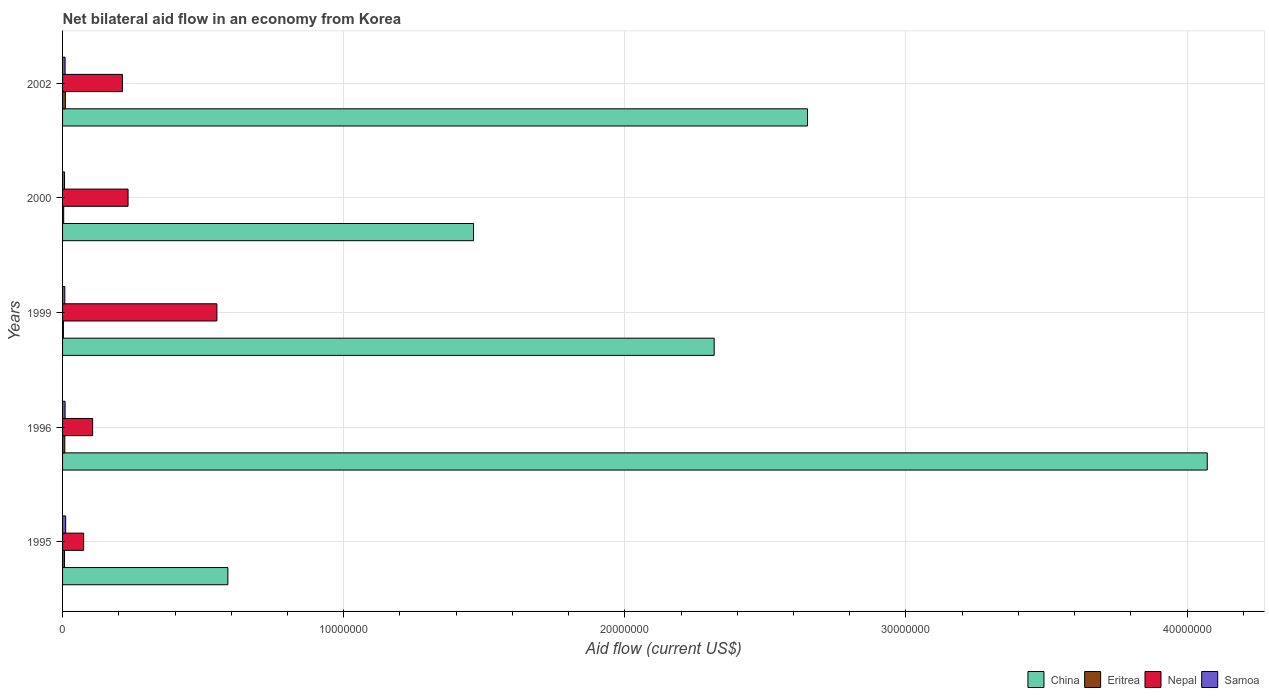Are the number of bars per tick equal to the number of legend labels?
Give a very brief answer. Yes. What is the net bilateral aid flow in Nepal in 2002?
Your answer should be very brief. 2.13e+06. Across all years, what is the maximum net bilateral aid flow in China?
Provide a short and direct response. 4.07e+07. Across all years, what is the minimum net bilateral aid flow in Eritrea?
Offer a very short reply. 3.00e+04. What is the total net bilateral aid flow in China in the graph?
Your response must be concise. 1.11e+08. What is the difference between the net bilateral aid flow in Samoa in 1999 and that in 2000?
Your response must be concise. 10000. What is the average net bilateral aid flow in Samoa per year?
Ensure brevity in your answer.  8.80e+04. In the year 1996, what is the difference between the net bilateral aid flow in China and net bilateral aid flow in Samoa?
Ensure brevity in your answer.  4.06e+07. What is the ratio of the net bilateral aid flow in Samoa in 1999 to that in 2000?
Your answer should be very brief. 1.14. Is the difference between the net bilateral aid flow in China in 1995 and 2002 greater than the difference between the net bilateral aid flow in Samoa in 1995 and 2002?
Provide a succinct answer. No. In how many years, is the net bilateral aid flow in Eritrea greater than the average net bilateral aid flow in Eritrea taken over all years?
Give a very brief answer. 3. What does the 4th bar from the top in 1996 represents?
Give a very brief answer. China. What does the 1st bar from the bottom in 2002 represents?
Keep it short and to the point. China. Are all the bars in the graph horizontal?
Offer a very short reply. Yes. How many years are there in the graph?
Provide a succinct answer. 5. Does the graph contain any zero values?
Offer a very short reply. No. Where does the legend appear in the graph?
Your answer should be compact. Bottom right. How many legend labels are there?
Offer a very short reply. 4. What is the title of the graph?
Your answer should be compact. Net bilateral aid flow in an economy from Korea. Does "Arab World" appear as one of the legend labels in the graph?
Your response must be concise. No. What is the label or title of the X-axis?
Keep it short and to the point. Aid flow (current US$). What is the Aid flow (current US$) of China in 1995?
Offer a very short reply. 5.88e+06. What is the Aid flow (current US$) in Eritrea in 1995?
Provide a short and direct response. 7.00e+04. What is the Aid flow (current US$) of Nepal in 1995?
Provide a succinct answer. 7.50e+05. What is the Aid flow (current US$) of Samoa in 1995?
Provide a short and direct response. 1.10e+05. What is the Aid flow (current US$) of China in 1996?
Ensure brevity in your answer.  4.07e+07. What is the Aid flow (current US$) of Eritrea in 1996?
Make the answer very short. 8.00e+04. What is the Aid flow (current US$) of Nepal in 1996?
Give a very brief answer. 1.07e+06. What is the Aid flow (current US$) in China in 1999?
Your answer should be compact. 2.32e+07. What is the Aid flow (current US$) of Eritrea in 1999?
Provide a short and direct response. 3.00e+04. What is the Aid flow (current US$) in Nepal in 1999?
Offer a very short reply. 5.49e+06. What is the Aid flow (current US$) in China in 2000?
Your answer should be compact. 1.46e+07. What is the Aid flow (current US$) in Nepal in 2000?
Offer a terse response. 2.33e+06. What is the Aid flow (current US$) in China in 2002?
Provide a short and direct response. 2.65e+07. What is the Aid flow (current US$) of Nepal in 2002?
Make the answer very short. 2.13e+06. What is the Aid flow (current US$) in Samoa in 2002?
Provide a short and direct response. 9.00e+04. Across all years, what is the maximum Aid flow (current US$) in China?
Keep it short and to the point. 4.07e+07. Across all years, what is the maximum Aid flow (current US$) in Nepal?
Make the answer very short. 5.49e+06. Across all years, what is the minimum Aid flow (current US$) in China?
Your answer should be compact. 5.88e+06. Across all years, what is the minimum Aid flow (current US$) in Eritrea?
Your answer should be very brief. 3.00e+04. Across all years, what is the minimum Aid flow (current US$) of Nepal?
Provide a short and direct response. 7.50e+05. What is the total Aid flow (current US$) of China in the graph?
Make the answer very short. 1.11e+08. What is the total Aid flow (current US$) of Nepal in the graph?
Provide a short and direct response. 1.18e+07. What is the total Aid flow (current US$) in Samoa in the graph?
Keep it short and to the point. 4.40e+05. What is the difference between the Aid flow (current US$) in China in 1995 and that in 1996?
Offer a very short reply. -3.48e+07. What is the difference between the Aid flow (current US$) of Nepal in 1995 and that in 1996?
Provide a short and direct response. -3.20e+05. What is the difference between the Aid flow (current US$) in Samoa in 1995 and that in 1996?
Your response must be concise. 2.00e+04. What is the difference between the Aid flow (current US$) of China in 1995 and that in 1999?
Offer a very short reply. -1.73e+07. What is the difference between the Aid flow (current US$) of Eritrea in 1995 and that in 1999?
Make the answer very short. 4.00e+04. What is the difference between the Aid flow (current US$) in Nepal in 1995 and that in 1999?
Offer a very short reply. -4.74e+06. What is the difference between the Aid flow (current US$) of Samoa in 1995 and that in 1999?
Provide a short and direct response. 3.00e+04. What is the difference between the Aid flow (current US$) in China in 1995 and that in 2000?
Give a very brief answer. -8.74e+06. What is the difference between the Aid flow (current US$) of Eritrea in 1995 and that in 2000?
Ensure brevity in your answer.  3.00e+04. What is the difference between the Aid flow (current US$) in Nepal in 1995 and that in 2000?
Ensure brevity in your answer.  -1.58e+06. What is the difference between the Aid flow (current US$) of Samoa in 1995 and that in 2000?
Make the answer very short. 4.00e+04. What is the difference between the Aid flow (current US$) in China in 1995 and that in 2002?
Ensure brevity in your answer.  -2.06e+07. What is the difference between the Aid flow (current US$) in Eritrea in 1995 and that in 2002?
Offer a very short reply. -3.00e+04. What is the difference between the Aid flow (current US$) in Nepal in 1995 and that in 2002?
Your response must be concise. -1.38e+06. What is the difference between the Aid flow (current US$) of China in 1996 and that in 1999?
Offer a terse response. 1.75e+07. What is the difference between the Aid flow (current US$) in Eritrea in 1996 and that in 1999?
Provide a short and direct response. 5.00e+04. What is the difference between the Aid flow (current US$) of Nepal in 1996 and that in 1999?
Offer a very short reply. -4.42e+06. What is the difference between the Aid flow (current US$) in Samoa in 1996 and that in 1999?
Your response must be concise. 10000. What is the difference between the Aid flow (current US$) of China in 1996 and that in 2000?
Give a very brief answer. 2.61e+07. What is the difference between the Aid flow (current US$) in Nepal in 1996 and that in 2000?
Keep it short and to the point. -1.26e+06. What is the difference between the Aid flow (current US$) of China in 1996 and that in 2002?
Make the answer very short. 1.42e+07. What is the difference between the Aid flow (current US$) of Nepal in 1996 and that in 2002?
Keep it short and to the point. -1.06e+06. What is the difference between the Aid flow (current US$) in Samoa in 1996 and that in 2002?
Your answer should be compact. 0. What is the difference between the Aid flow (current US$) of China in 1999 and that in 2000?
Provide a short and direct response. 8.56e+06. What is the difference between the Aid flow (current US$) in Nepal in 1999 and that in 2000?
Your answer should be very brief. 3.16e+06. What is the difference between the Aid flow (current US$) in China in 1999 and that in 2002?
Offer a terse response. -3.32e+06. What is the difference between the Aid flow (current US$) of Nepal in 1999 and that in 2002?
Your answer should be very brief. 3.36e+06. What is the difference between the Aid flow (current US$) in Samoa in 1999 and that in 2002?
Ensure brevity in your answer.  -10000. What is the difference between the Aid flow (current US$) in China in 2000 and that in 2002?
Provide a succinct answer. -1.19e+07. What is the difference between the Aid flow (current US$) of China in 1995 and the Aid flow (current US$) of Eritrea in 1996?
Make the answer very short. 5.80e+06. What is the difference between the Aid flow (current US$) of China in 1995 and the Aid flow (current US$) of Nepal in 1996?
Provide a short and direct response. 4.81e+06. What is the difference between the Aid flow (current US$) of China in 1995 and the Aid flow (current US$) of Samoa in 1996?
Provide a short and direct response. 5.79e+06. What is the difference between the Aid flow (current US$) of Eritrea in 1995 and the Aid flow (current US$) of Nepal in 1996?
Your answer should be very brief. -1.00e+06. What is the difference between the Aid flow (current US$) in Eritrea in 1995 and the Aid flow (current US$) in Samoa in 1996?
Offer a very short reply. -2.00e+04. What is the difference between the Aid flow (current US$) in Nepal in 1995 and the Aid flow (current US$) in Samoa in 1996?
Offer a very short reply. 6.60e+05. What is the difference between the Aid flow (current US$) in China in 1995 and the Aid flow (current US$) in Eritrea in 1999?
Provide a short and direct response. 5.85e+06. What is the difference between the Aid flow (current US$) in China in 1995 and the Aid flow (current US$) in Samoa in 1999?
Offer a very short reply. 5.80e+06. What is the difference between the Aid flow (current US$) of Eritrea in 1995 and the Aid flow (current US$) of Nepal in 1999?
Your answer should be compact. -5.42e+06. What is the difference between the Aid flow (current US$) in Eritrea in 1995 and the Aid flow (current US$) in Samoa in 1999?
Your answer should be very brief. -10000. What is the difference between the Aid flow (current US$) of Nepal in 1995 and the Aid flow (current US$) of Samoa in 1999?
Keep it short and to the point. 6.70e+05. What is the difference between the Aid flow (current US$) in China in 1995 and the Aid flow (current US$) in Eritrea in 2000?
Offer a very short reply. 5.84e+06. What is the difference between the Aid flow (current US$) in China in 1995 and the Aid flow (current US$) in Nepal in 2000?
Ensure brevity in your answer.  3.55e+06. What is the difference between the Aid flow (current US$) of China in 1995 and the Aid flow (current US$) of Samoa in 2000?
Give a very brief answer. 5.81e+06. What is the difference between the Aid flow (current US$) of Eritrea in 1995 and the Aid flow (current US$) of Nepal in 2000?
Offer a very short reply. -2.26e+06. What is the difference between the Aid flow (current US$) of Nepal in 1995 and the Aid flow (current US$) of Samoa in 2000?
Provide a short and direct response. 6.80e+05. What is the difference between the Aid flow (current US$) in China in 1995 and the Aid flow (current US$) in Eritrea in 2002?
Offer a very short reply. 5.78e+06. What is the difference between the Aid flow (current US$) in China in 1995 and the Aid flow (current US$) in Nepal in 2002?
Offer a very short reply. 3.75e+06. What is the difference between the Aid flow (current US$) of China in 1995 and the Aid flow (current US$) of Samoa in 2002?
Provide a succinct answer. 5.79e+06. What is the difference between the Aid flow (current US$) of Eritrea in 1995 and the Aid flow (current US$) of Nepal in 2002?
Provide a succinct answer. -2.06e+06. What is the difference between the Aid flow (current US$) in Eritrea in 1995 and the Aid flow (current US$) in Samoa in 2002?
Offer a very short reply. -2.00e+04. What is the difference between the Aid flow (current US$) of Nepal in 1995 and the Aid flow (current US$) of Samoa in 2002?
Make the answer very short. 6.60e+05. What is the difference between the Aid flow (current US$) of China in 1996 and the Aid flow (current US$) of Eritrea in 1999?
Your answer should be very brief. 4.07e+07. What is the difference between the Aid flow (current US$) of China in 1996 and the Aid flow (current US$) of Nepal in 1999?
Ensure brevity in your answer.  3.52e+07. What is the difference between the Aid flow (current US$) in China in 1996 and the Aid flow (current US$) in Samoa in 1999?
Make the answer very short. 4.06e+07. What is the difference between the Aid flow (current US$) of Eritrea in 1996 and the Aid flow (current US$) of Nepal in 1999?
Make the answer very short. -5.41e+06. What is the difference between the Aid flow (current US$) in Eritrea in 1996 and the Aid flow (current US$) in Samoa in 1999?
Your answer should be very brief. 0. What is the difference between the Aid flow (current US$) in Nepal in 1996 and the Aid flow (current US$) in Samoa in 1999?
Make the answer very short. 9.90e+05. What is the difference between the Aid flow (current US$) in China in 1996 and the Aid flow (current US$) in Eritrea in 2000?
Offer a terse response. 4.07e+07. What is the difference between the Aid flow (current US$) in China in 1996 and the Aid flow (current US$) in Nepal in 2000?
Offer a terse response. 3.84e+07. What is the difference between the Aid flow (current US$) of China in 1996 and the Aid flow (current US$) of Samoa in 2000?
Give a very brief answer. 4.06e+07. What is the difference between the Aid flow (current US$) in Eritrea in 1996 and the Aid flow (current US$) in Nepal in 2000?
Your answer should be compact. -2.25e+06. What is the difference between the Aid flow (current US$) of Eritrea in 1996 and the Aid flow (current US$) of Samoa in 2000?
Your response must be concise. 10000. What is the difference between the Aid flow (current US$) in China in 1996 and the Aid flow (current US$) in Eritrea in 2002?
Give a very brief answer. 4.06e+07. What is the difference between the Aid flow (current US$) of China in 1996 and the Aid flow (current US$) of Nepal in 2002?
Give a very brief answer. 3.86e+07. What is the difference between the Aid flow (current US$) of China in 1996 and the Aid flow (current US$) of Samoa in 2002?
Provide a succinct answer. 4.06e+07. What is the difference between the Aid flow (current US$) in Eritrea in 1996 and the Aid flow (current US$) in Nepal in 2002?
Keep it short and to the point. -2.05e+06. What is the difference between the Aid flow (current US$) in Eritrea in 1996 and the Aid flow (current US$) in Samoa in 2002?
Keep it short and to the point. -10000. What is the difference between the Aid flow (current US$) in Nepal in 1996 and the Aid flow (current US$) in Samoa in 2002?
Provide a succinct answer. 9.80e+05. What is the difference between the Aid flow (current US$) of China in 1999 and the Aid flow (current US$) of Eritrea in 2000?
Your answer should be very brief. 2.31e+07. What is the difference between the Aid flow (current US$) in China in 1999 and the Aid flow (current US$) in Nepal in 2000?
Your response must be concise. 2.08e+07. What is the difference between the Aid flow (current US$) of China in 1999 and the Aid flow (current US$) of Samoa in 2000?
Make the answer very short. 2.31e+07. What is the difference between the Aid flow (current US$) of Eritrea in 1999 and the Aid flow (current US$) of Nepal in 2000?
Make the answer very short. -2.30e+06. What is the difference between the Aid flow (current US$) in Eritrea in 1999 and the Aid flow (current US$) in Samoa in 2000?
Keep it short and to the point. -4.00e+04. What is the difference between the Aid flow (current US$) of Nepal in 1999 and the Aid flow (current US$) of Samoa in 2000?
Offer a terse response. 5.42e+06. What is the difference between the Aid flow (current US$) of China in 1999 and the Aid flow (current US$) of Eritrea in 2002?
Offer a terse response. 2.31e+07. What is the difference between the Aid flow (current US$) of China in 1999 and the Aid flow (current US$) of Nepal in 2002?
Keep it short and to the point. 2.10e+07. What is the difference between the Aid flow (current US$) in China in 1999 and the Aid flow (current US$) in Samoa in 2002?
Offer a very short reply. 2.31e+07. What is the difference between the Aid flow (current US$) in Eritrea in 1999 and the Aid flow (current US$) in Nepal in 2002?
Offer a very short reply. -2.10e+06. What is the difference between the Aid flow (current US$) in Eritrea in 1999 and the Aid flow (current US$) in Samoa in 2002?
Provide a short and direct response. -6.00e+04. What is the difference between the Aid flow (current US$) of Nepal in 1999 and the Aid flow (current US$) of Samoa in 2002?
Provide a short and direct response. 5.40e+06. What is the difference between the Aid flow (current US$) of China in 2000 and the Aid flow (current US$) of Eritrea in 2002?
Offer a very short reply. 1.45e+07. What is the difference between the Aid flow (current US$) of China in 2000 and the Aid flow (current US$) of Nepal in 2002?
Offer a terse response. 1.25e+07. What is the difference between the Aid flow (current US$) in China in 2000 and the Aid flow (current US$) in Samoa in 2002?
Offer a terse response. 1.45e+07. What is the difference between the Aid flow (current US$) of Eritrea in 2000 and the Aid flow (current US$) of Nepal in 2002?
Make the answer very short. -2.09e+06. What is the difference between the Aid flow (current US$) in Nepal in 2000 and the Aid flow (current US$) in Samoa in 2002?
Offer a very short reply. 2.24e+06. What is the average Aid flow (current US$) in China per year?
Your answer should be compact. 2.22e+07. What is the average Aid flow (current US$) of Eritrea per year?
Offer a terse response. 6.40e+04. What is the average Aid flow (current US$) of Nepal per year?
Provide a short and direct response. 2.35e+06. What is the average Aid flow (current US$) of Samoa per year?
Give a very brief answer. 8.80e+04. In the year 1995, what is the difference between the Aid flow (current US$) of China and Aid flow (current US$) of Eritrea?
Offer a terse response. 5.81e+06. In the year 1995, what is the difference between the Aid flow (current US$) of China and Aid flow (current US$) of Nepal?
Give a very brief answer. 5.13e+06. In the year 1995, what is the difference between the Aid flow (current US$) of China and Aid flow (current US$) of Samoa?
Make the answer very short. 5.77e+06. In the year 1995, what is the difference between the Aid flow (current US$) in Eritrea and Aid flow (current US$) in Nepal?
Your answer should be very brief. -6.80e+05. In the year 1995, what is the difference between the Aid flow (current US$) in Nepal and Aid flow (current US$) in Samoa?
Offer a very short reply. 6.40e+05. In the year 1996, what is the difference between the Aid flow (current US$) of China and Aid flow (current US$) of Eritrea?
Your response must be concise. 4.06e+07. In the year 1996, what is the difference between the Aid flow (current US$) of China and Aid flow (current US$) of Nepal?
Provide a short and direct response. 3.96e+07. In the year 1996, what is the difference between the Aid flow (current US$) of China and Aid flow (current US$) of Samoa?
Offer a terse response. 4.06e+07. In the year 1996, what is the difference between the Aid flow (current US$) of Eritrea and Aid flow (current US$) of Nepal?
Your answer should be very brief. -9.90e+05. In the year 1996, what is the difference between the Aid flow (current US$) in Eritrea and Aid flow (current US$) in Samoa?
Your response must be concise. -10000. In the year 1996, what is the difference between the Aid flow (current US$) of Nepal and Aid flow (current US$) of Samoa?
Provide a short and direct response. 9.80e+05. In the year 1999, what is the difference between the Aid flow (current US$) of China and Aid flow (current US$) of Eritrea?
Provide a short and direct response. 2.32e+07. In the year 1999, what is the difference between the Aid flow (current US$) of China and Aid flow (current US$) of Nepal?
Make the answer very short. 1.77e+07. In the year 1999, what is the difference between the Aid flow (current US$) in China and Aid flow (current US$) in Samoa?
Give a very brief answer. 2.31e+07. In the year 1999, what is the difference between the Aid flow (current US$) of Eritrea and Aid flow (current US$) of Nepal?
Your response must be concise. -5.46e+06. In the year 1999, what is the difference between the Aid flow (current US$) of Eritrea and Aid flow (current US$) of Samoa?
Provide a succinct answer. -5.00e+04. In the year 1999, what is the difference between the Aid flow (current US$) in Nepal and Aid flow (current US$) in Samoa?
Offer a terse response. 5.41e+06. In the year 2000, what is the difference between the Aid flow (current US$) in China and Aid flow (current US$) in Eritrea?
Provide a short and direct response. 1.46e+07. In the year 2000, what is the difference between the Aid flow (current US$) in China and Aid flow (current US$) in Nepal?
Your answer should be compact. 1.23e+07. In the year 2000, what is the difference between the Aid flow (current US$) in China and Aid flow (current US$) in Samoa?
Your answer should be compact. 1.46e+07. In the year 2000, what is the difference between the Aid flow (current US$) of Eritrea and Aid flow (current US$) of Nepal?
Offer a very short reply. -2.29e+06. In the year 2000, what is the difference between the Aid flow (current US$) in Nepal and Aid flow (current US$) in Samoa?
Ensure brevity in your answer.  2.26e+06. In the year 2002, what is the difference between the Aid flow (current US$) in China and Aid flow (current US$) in Eritrea?
Ensure brevity in your answer.  2.64e+07. In the year 2002, what is the difference between the Aid flow (current US$) in China and Aid flow (current US$) in Nepal?
Ensure brevity in your answer.  2.44e+07. In the year 2002, what is the difference between the Aid flow (current US$) in China and Aid flow (current US$) in Samoa?
Keep it short and to the point. 2.64e+07. In the year 2002, what is the difference between the Aid flow (current US$) of Eritrea and Aid flow (current US$) of Nepal?
Provide a succinct answer. -2.03e+06. In the year 2002, what is the difference between the Aid flow (current US$) of Eritrea and Aid flow (current US$) of Samoa?
Provide a short and direct response. 10000. In the year 2002, what is the difference between the Aid flow (current US$) in Nepal and Aid flow (current US$) in Samoa?
Keep it short and to the point. 2.04e+06. What is the ratio of the Aid flow (current US$) in China in 1995 to that in 1996?
Your response must be concise. 0.14. What is the ratio of the Aid flow (current US$) of Eritrea in 1995 to that in 1996?
Offer a terse response. 0.88. What is the ratio of the Aid flow (current US$) in Nepal in 1995 to that in 1996?
Keep it short and to the point. 0.7. What is the ratio of the Aid flow (current US$) in Samoa in 1995 to that in 1996?
Make the answer very short. 1.22. What is the ratio of the Aid flow (current US$) of China in 1995 to that in 1999?
Offer a terse response. 0.25. What is the ratio of the Aid flow (current US$) in Eritrea in 1995 to that in 1999?
Make the answer very short. 2.33. What is the ratio of the Aid flow (current US$) in Nepal in 1995 to that in 1999?
Your answer should be very brief. 0.14. What is the ratio of the Aid flow (current US$) in Samoa in 1995 to that in 1999?
Offer a terse response. 1.38. What is the ratio of the Aid flow (current US$) in China in 1995 to that in 2000?
Offer a very short reply. 0.4. What is the ratio of the Aid flow (current US$) in Eritrea in 1995 to that in 2000?
Your answer should be very brief. 1.75. What is the ratio of the Aid flow (current US$) of Nepal in 1995 to that in 2000?
Your answer should be very brief. 0.32. What is the ratio of the Aid flow (current US$) of Samoa in 1995 to that in 2000?
Offer a terse response. 1.57. What is the ratio of the Aid flow (current US$) of China in 1995 to that in 2002?
Your response must be concise. 0.22. What is the ratio of the Aid flow (current US$) of Eritrea in 1995 to that in 2002?
Ensure brevity in your answer.  0.7. What is the ratio of the Aid flow (current US$) in Nepal in 1995 to that in 2002?
Provide a short and direct response. 0.35. What is the ratio of the Aid flow (current US$) in Samoa in 1995 to that in 2002?
Your response must be concise. 1.22. What is the ratio of the Aid flow (current US$) of China in 1996 to that in 1999?
Provide a succinct answer. 1.76. What is the ratio of the Aid flow (current US$) in Eritrea in 1996 to that in 1999?
Your answer should be very brief. 2.67. What is the ratio of the Aid flow (current US$) in Nepal in 1996 to that in 1999?
Give a very brief answer. 0.19. What is the ratio of the Aid flow (current US$) of Samoa in 1996 to that in 1999?
Give a very brief answer. 1.12. What is the ratio of the Aid flow (current US$) of China in 1996 to that in 2000?
Your answer should be very brief. 2.79. What is the ratio of the Aid flow (current US$) in Nepal in 1996 to that in 2000?
Make the answer very short. 0.46. What is the ratio of the Aid flow (current US$) in Samoa in 1996 to that in 2000?
Give a very brief answer. 1.29. What is the ratio of the Aid flow (current US$) of China in 1996 to that in 2002?
Make the answer very short. 1.54. What is the ratio of the Aid flow (current US$) in Eritrea in 1996 to that in 2002?
Provide a short and direct response. 0.8. What is the ratio of the Aid flow (current US$) in Nepal in 1996 to that in 2002?
Your answer should be very brief. 0.5. What is the ratio of the Aid flow (current US$) in Samoa in 1996 to that in 2002?
Provide a short and direct response. 1. What is the ratio of the Aid flow (current US$) in China in 1999 to that in 2000?
Make the answer very short. 1.59. What is the ratio of the Aid flow (current US$) of Eritrea in 1999 to that in 2000?
Give a very brief answer. 0.75. What is the ratio of the Aid flow (current US$) of Nepal in 1999 to that in 2000?
Make the answer very short. 2.36. What is the ratio of the Aid flow (current US$) in Samoa in 1999 to that in 2000?
Offer a very short reply. 1.14. What is the ratio of the Aid flow (current US$) in China in 1999 to that in 2002?
Your answer should be very brief. 0.87. What is the ratio of the Aid flow (current US$) in Eritrea in 1999 to that in 2002?
Ensure brevity in your answer.  0.3. What is the ratio of the Aid flow (current US$) in Nepal in 1999 to that in 2002?
Your answer should be very brief. 2.58. What is the ratio of the Aid flow (current US$) of Samoa in 1999 to that in 2002?
Ensure brevity in your answer.  0.89. What is the ratio of the Aid flow (current US$) of China in 2000 to that in 2002?
Keep it short and to the point. 0.55. What is the ratio of the Aid flow (current US$) of Nepal in 2000 to that in 2002?
Keep it short and to the point. 1.09. What is the difference between the highest and the second highest Aid flow (current US$) of China?
Provide a succinct answer. 1.42e+07. What is the difference between the highest and the second highest Aid flow (current US$) of Nepal?
Your response must be concise. 3.16e+06. What is the difference between the highest and the second highest Aid flow (current US$) of Samoa?
Offer a very short reply. 2.00e+04. What is the difference between the highest and the lowest Aid flow (current US$) in China?
Provide a succinct answer. 3.48e+07. What is the difference between the highest and the lowest Aid flow (current US$) of Nepal?
Make the answer very short. 4.74e+06. What is the difference between the highest and the lowest Aid flow (current US$) in Samoa?
Provide a short and direct response. 4.00e+04. 